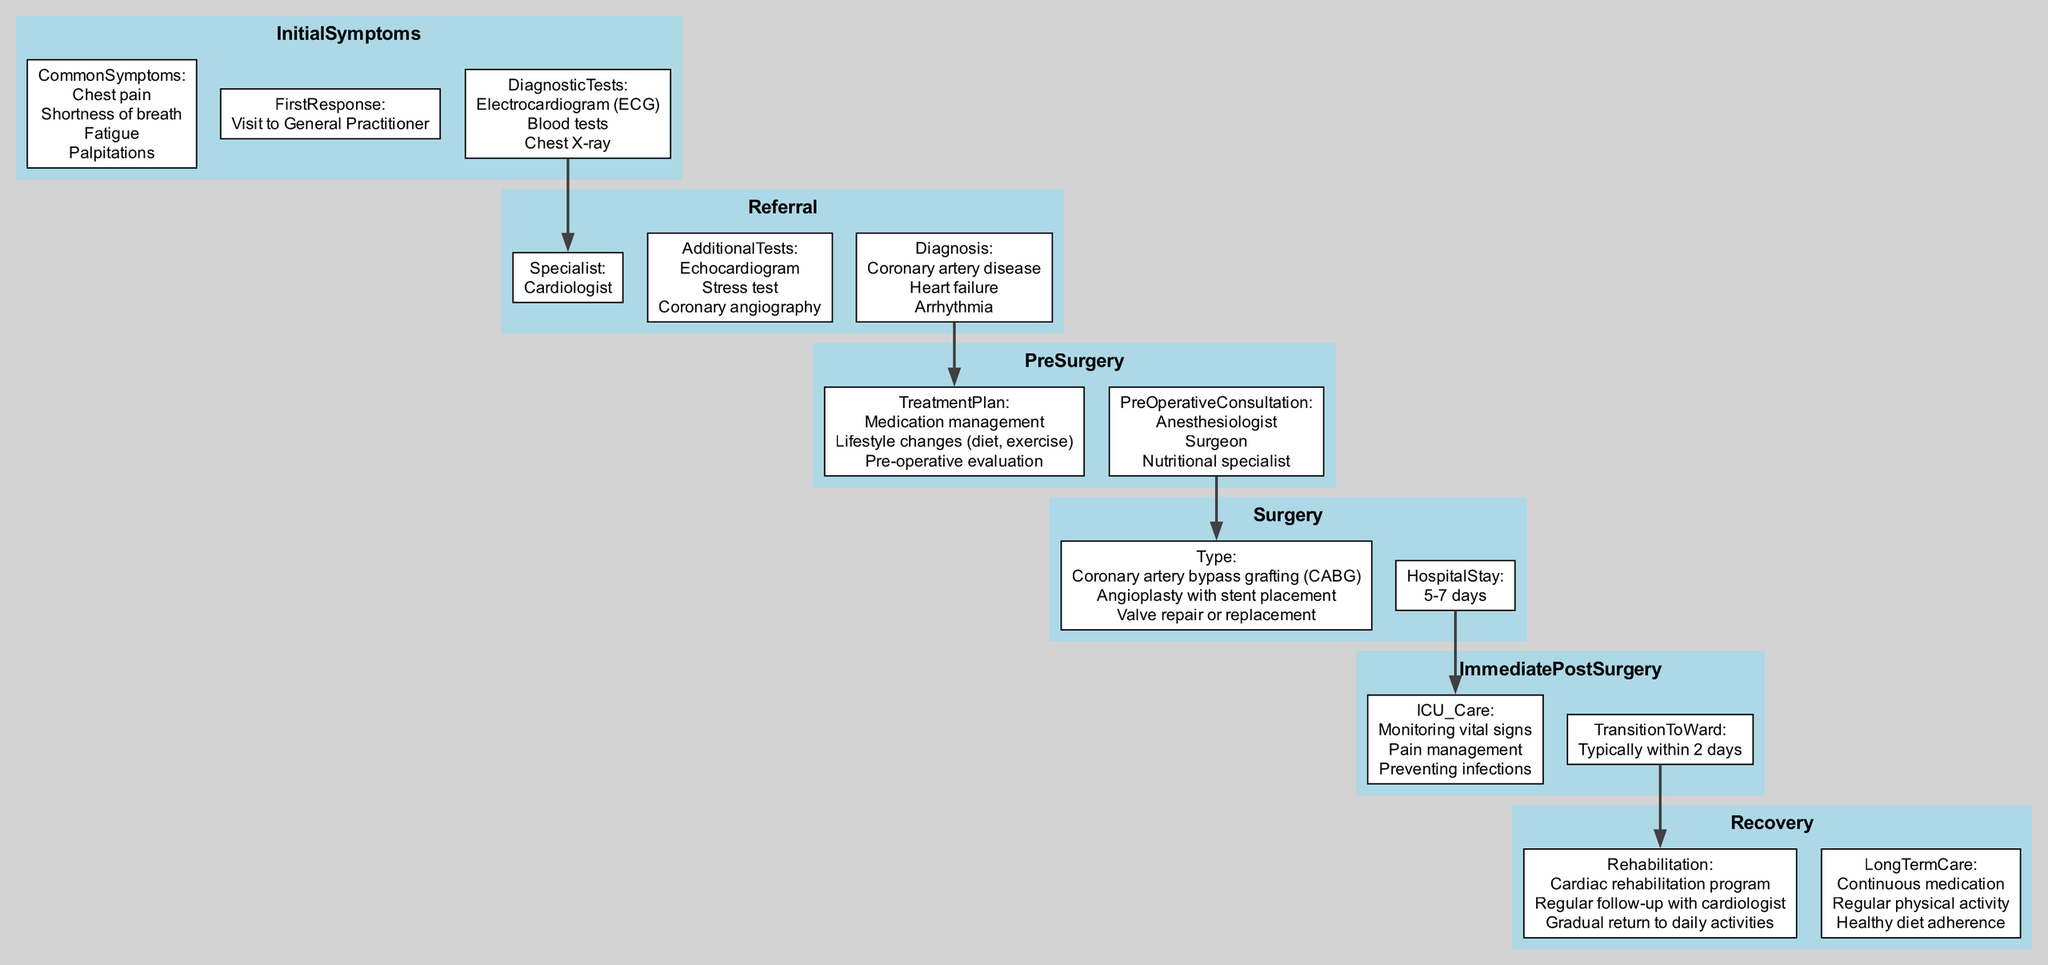What are the common symptoms listed in the Initial Symptoms stage? The diagram specifies that the common symptoms are chest pain, shortness of breath, fatigue, and palpitations. This information can be found under the InitialSymptoms node.
Answer: chest pain, shortness of breath, fatigue, palpitations How many diagnostic tests are mentioned in the Initial Symptoms stage? The diagram outlines three diagnostic tests (Electrocardiogram, Blood tests, and Chest X-ray) under the InitialSymptoms node, indicating the total count of tests.
Answer: 3 What is the first response for a patient experiencing initial symptoms? According to the diagram, the first response noted in the Initial Symptoms stage is a visit to the general practitioner.
Answer: Visit to General Practitioner Which specialist is the patient referred to after the Initial Symptoms stage? The diagram shows that the patient is referred to a cardiologist after the initial symptoms are evaluated, indicating a clear path to the next stage.
Answer: Cardiologist What are the three types of surgery listed in the Surgery stage? The diagram provides three types of surgery: Coronary artery bypass grafting, Angioplasty with stent placement, and Valve repair or replacement. These are clearly detailed in the Surgery node.
Answer: Coronary artery bypass grafting, Angioplasty with stent placement, Valve repair or replacement What is the typical hospital stay duration mentioned in the Surgery stage? The diagram specifies that the typical hospital stay is between 5-7 days. This information can be found under the Surgery node as it directly addresses the duration post-surgery.
Answer: 5-7 days What does the patient typically transition to after Immediate Post-Surgery care? The diagram states that patients typically transition to the ward within 2 days after immediate post-surgery care, highlighting the flow of care in this pathway.
Answer: Typically within 2 days What aspects are included in the Recovery stage's long-term care? The Recovery stage outlines three aspects of long-term care: continuous medication, regular physical activity, and healthy diet adherence, which are critical for the patient’s overall wellbeing post-recovery.
Answer: Continuous medication, Regular physical activity, Healthy diet adherence 